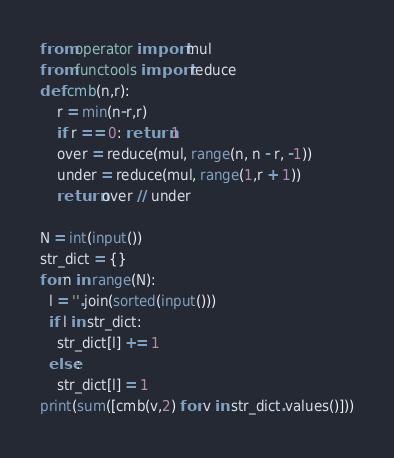<code> <loc_0><loc_0><loc_500><loc_500><_Python_>from operator import mul
from functools import reduce
def cmb(n,r):
    r = min(n-r,r)
    if r == 0: return 1
    over = reduce(mul, range(n, n - r, -1))
    under = reduce(mul, range(1,r + 1))
    return over // under

N = int(input())
str_dict = {}
for n in range(N):
  l = ''.join(sorted(input()))
  if l in str_dict:
    str_dict[l] += 1
  else:
    str_dict[l] = 1
print(sum([cmb(v,2) for v in str_dict.values()]))</code> 